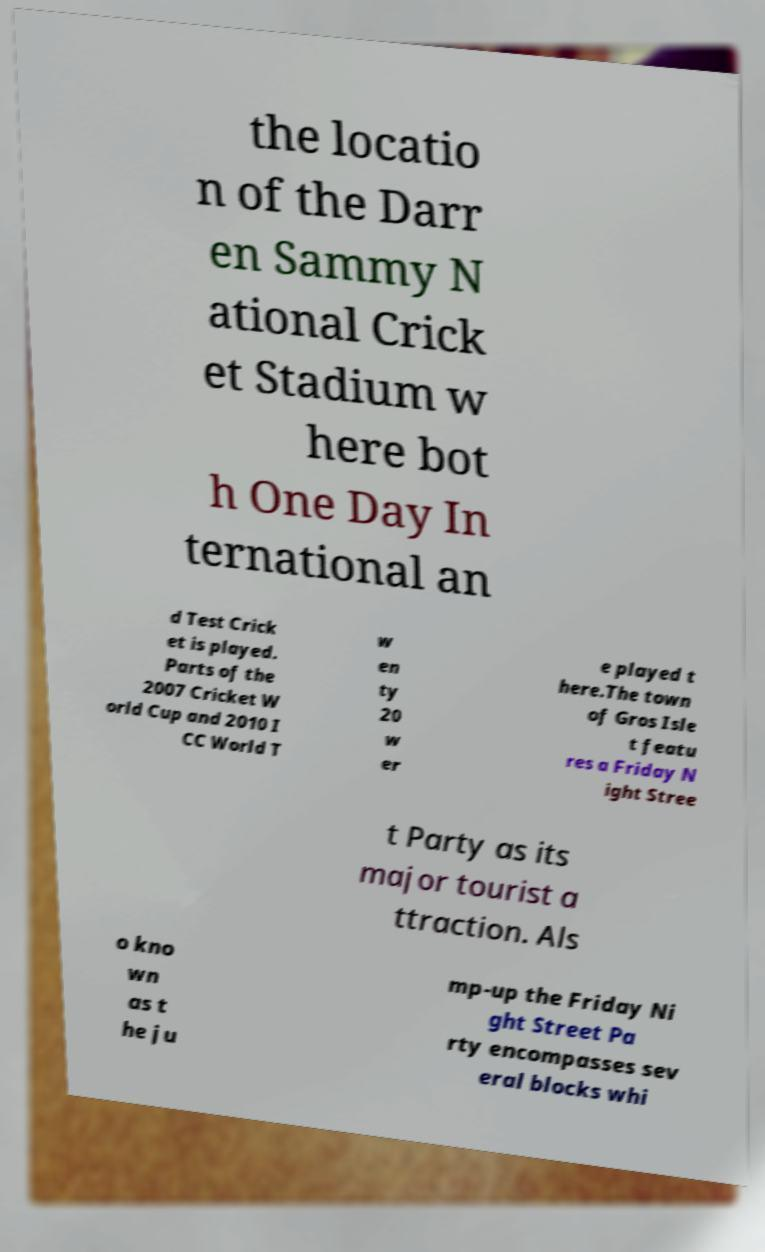Please identify and transcribe the text found in this image. the locatio n of the Darr en Sammy N ational Crick et Stadium w here bot h One Day In ternational an d Test Crick et is played. Parts of the 2007 Cricket W orld Cup and 2010 I CC World T w en ty 20 w er e played t here.The town of Gros Isle t featu res a Friday N ight Stree t Party as its major tourist a ttraction. Als o kno wn as t he ju mp-up the Friday Ni ght Street Pa rty encompasses sev eral blocks whi 